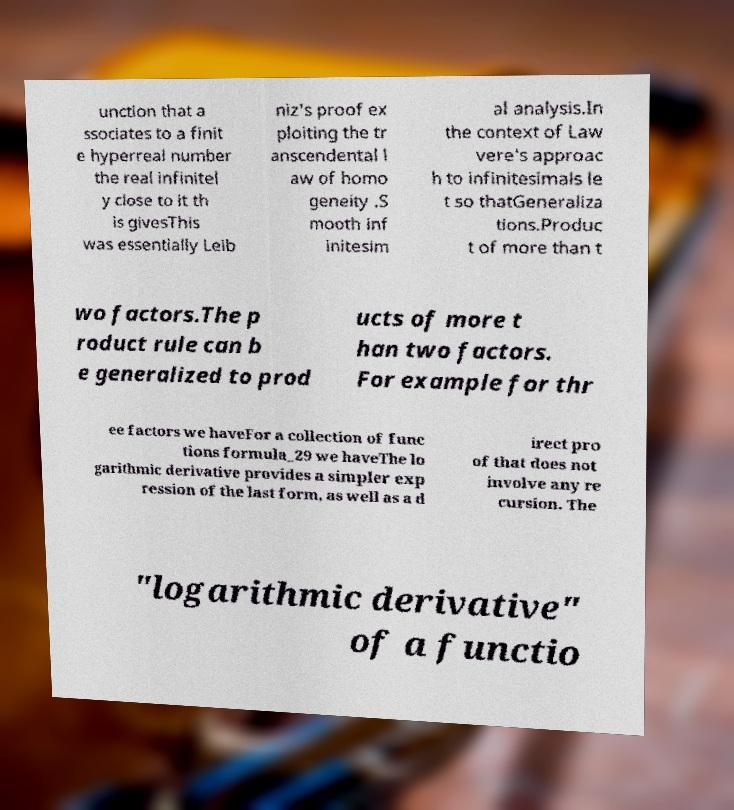Could you extract and type out the text from this image? unction that a ssociates to a finit e hyperreal number the real infinitel y close to it th is givesThis was essentially Leib niz's proof ex ploiting the tr anscendental l aw of homo geneity .S mooth inf initesim al analysis.In the context of Law vere's approac h to infinitesimals le t so thatGeneraliza tions.Produc t of more than t wo factors.The p roduct rule can b e generalized to prod ucts of more t han two factors. For example for thr ee factors we haveFor a collection of func tions formula_29 we haveThe lo garithmic derivative provides a simpler exp ression of the last form, as well as a d irect pro of that does not involve any re cursion. The "logarithmic derivative" of a functio 